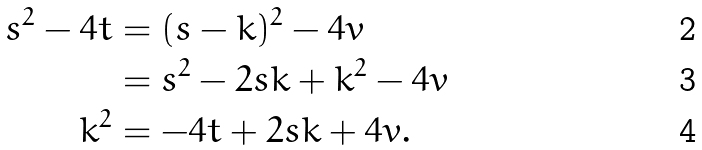Convert formula to latex. <formula><loc_0><loc_0><loc_500><loc_500>s ^ { 2 } - 4 t & = ( s - k ) ^ { 2 } - 4 v \\ & = s ^ { 2 } - 2 s k + k ^ { 2 } - 4 v \\ k ^ { 2 } & = - 4 t + 2 s k + 4 v .</formula> 